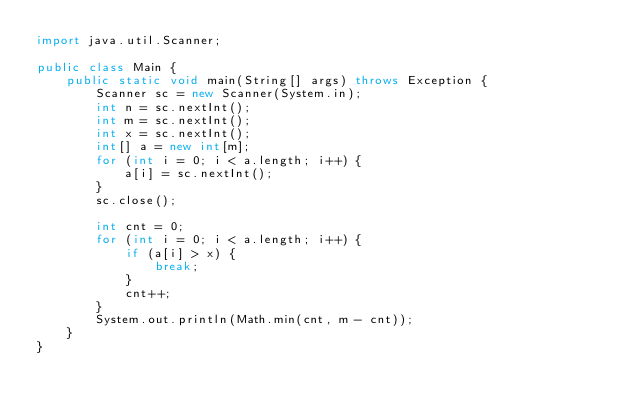Convert code to text. <code><loc_0><loc_0><loc_500><loc_500><_Java_>import java.util.Scanner;

public class Main {
	public static void main(String[] args) throws Exception {
		Scanner sc = new Scanner(System.in);
		int n = sc.nextInt();
		int m = sc.nextInt();
		int x = sc.nextInt();
		int[] a = new int[m];
		for (int i = 0; i < a.length; i++) {
			a[i] = sc.nextInt();
		}
		sc.close();

		int cnt = 0;
		for (int i = 0; i < a.length; i++) {
			if (a[i] > x) {
				break;
			}
			cnt++;
		}
		System.out.println(Math.min(cnt, m - cnt));
	}
}
</code> 